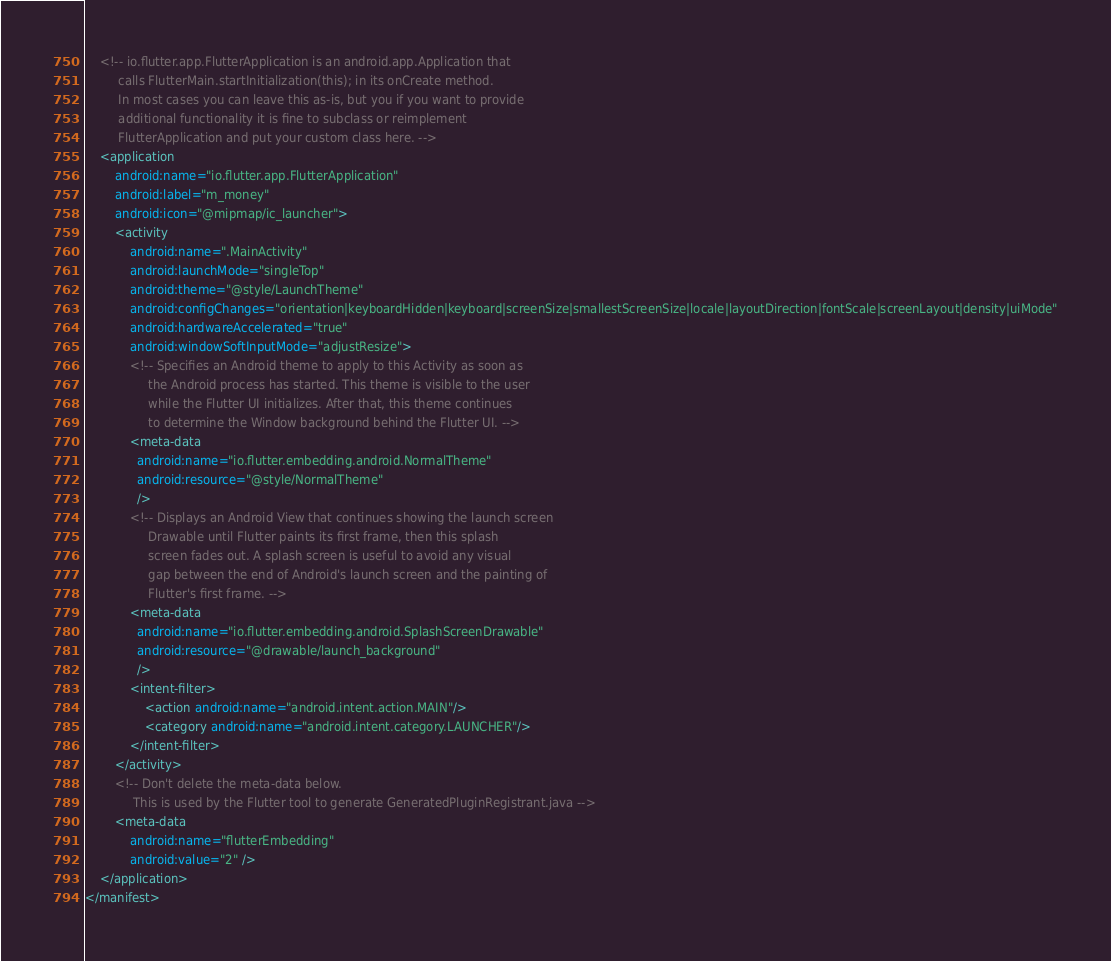Convert code to text. <code><loc_0><loc_0><loc_500><loc_500><_XML_>    <!-- io.flutter.app.FlutterApplication is an android.app.Application that
         calls FlutterMain.startInitialization(this); in its onCreate method.
         In most cases you can leave this as-is, but you if you want to provide
         additional functionality it is fine to subclass or reimplement
         FlutterApplication and put your custom class here. -->
    <application
        android:name="io.flutter.app.FlutterApplication"
        android:label="m_money"
        android:icon="@mipmap/ic_launcher">
        <activity
            android:name=".MainActivity"
            android:launchMode="singleTop"
            android:theme="@style/LaunchTheme"
            android:configChanges="orientation|keyboardHidden|keyboard|screenSize|smallestScreenSize|locale|layoutDirection|fontScale|screenLayout|density|uiMode"
            android:hardwareAccelerated="true"
            android:windowSoftInputMode="adjustResize">
            <!-- Specifies an Android theme to apply to this Activity as soon as
                 the Android process has started. This theme is visible to the user
                 while the Flutter UI initializes. After that, this theme continues
                 to determine the Window background behind the Flutter UI. -->
            <meta-data
              android:name="io.flutter.embedding.android.NormalTheme"
              android:resource="@style/NormalTheme"
              />
            <!-- Displays an Android View that continues showing the launch screen
                 Drawable until Flutter paints its first frame, then this splash
                 screen fades out. A splash screen is useful to avoid any visual
                 gap between the end of Android's launch screen and the painting of
                 Flutter's first frame. -->
            <meta-data
              android:name="io.flutter.embedding.android.SplashScreenDrawable"
              android:resource="@drawable/launch_background"
              />
            <intent-filter>
                <action android:name="android.intent.action.MAIN"/>
                <category android:name="android.intent.category.LAUNCHER"/>
            </intent-filter>
        </activity>
        <!-- Don't delete the meta-data below.
             This is used by the Flutter tool to generate GeneratedPluginRegistrant.java -->
        <meta-data
            android:name="flutterEmbedding"
            android:value="2" />
    </application>
</manifest>
</code> 